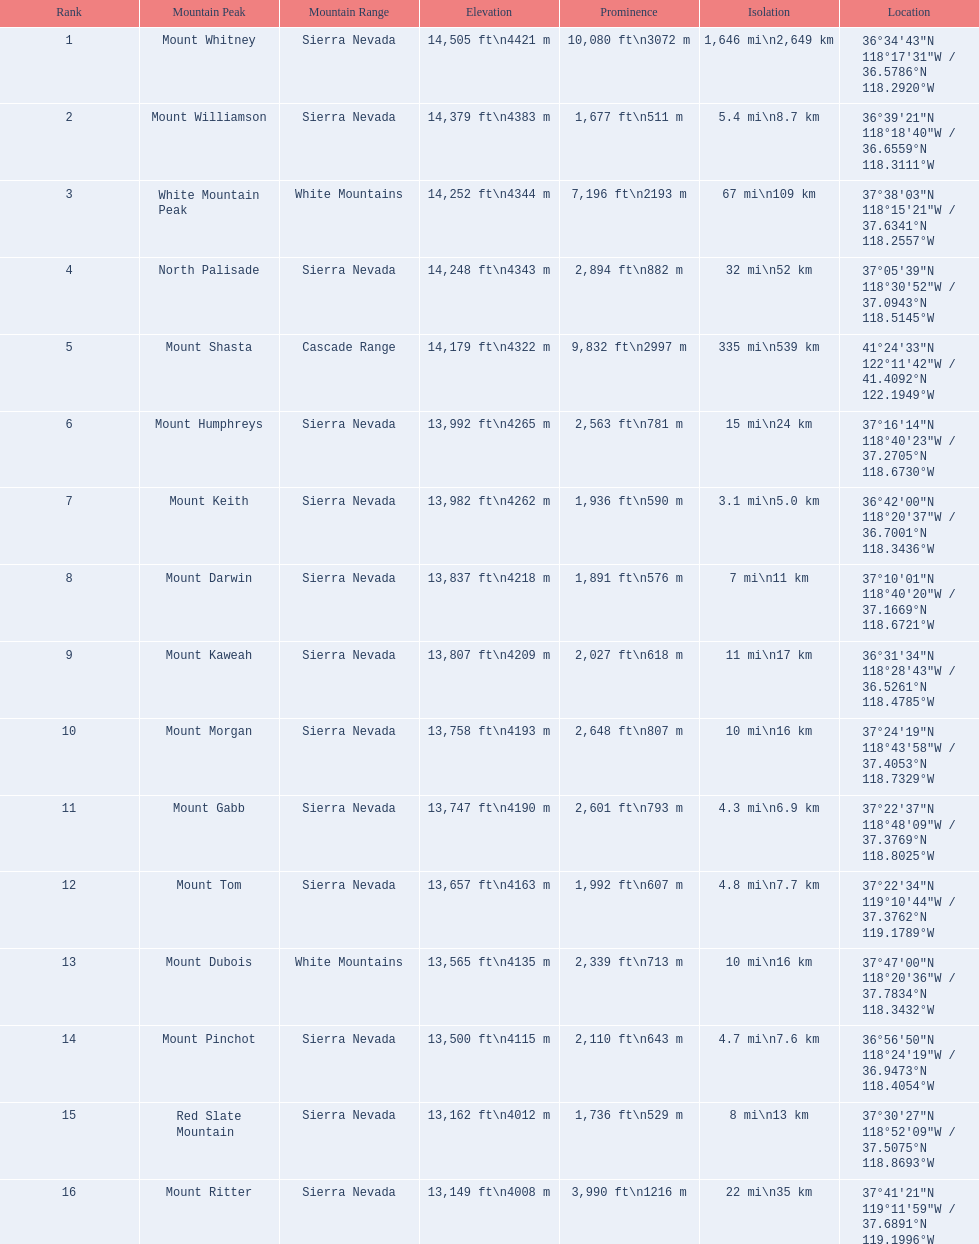Which mountain pinnacle is in the white mountains range? White Mountain Peak. Which mountain is in the sierra nevada region? Mount Whitney. Which mountain is the exclusive one in the cascade range? Mount Shasta. 